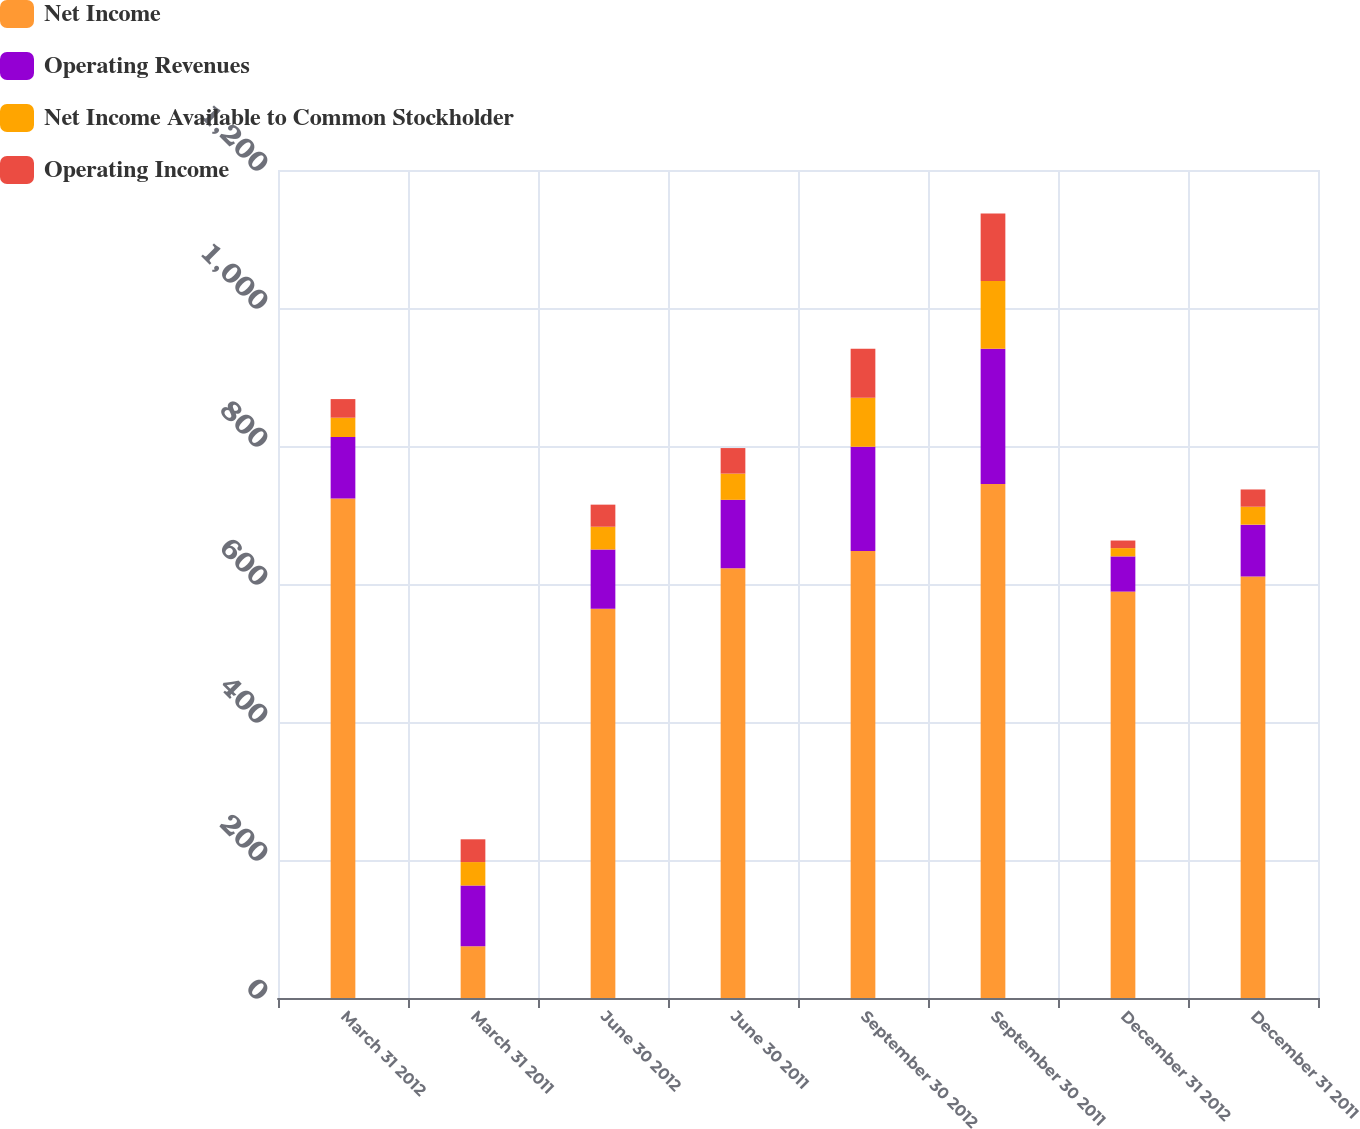<chart> <loc_0><loc_0><loc_500><loc_500><stacked_bar_chart><ecel><fcel>March 31 2012<fcel>March 31 2011<fcel>June 30 2012<fcel>June 30 2011<fcel>September 30 2012<fcel>September 30 2011<fcel>December 31 2012<fcel>December 31 2011<nl><fcel>Net Income<fcel>724<fcel>75<fcel>564<fcel>623<fcel>648<fcel>745<fcel>589<fcel>611<nl><fcel>Operating Revenues<fcel>89<fcel>88<fcel>86<fcel>99<fcel>151<fcel>196<fcel>51<fcel>75<nl><fcel>Net Income Available to Common Stockholder<fcel>28<fcel>34<fcel>33<fcel>38<fcel>71<fcel>98<fcel>12<fcel>26<nl><fcel>Operating Income<fcel>27<fcel>33<fcel>32<fcel>37<fcel>71<fcel>98<fcel>11<fcel>25<nl></chart> 